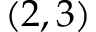Convert formula to latex. <formula><loc_0><loc_0><loc_500><loc_500>( 2 , 3 )</formula> 